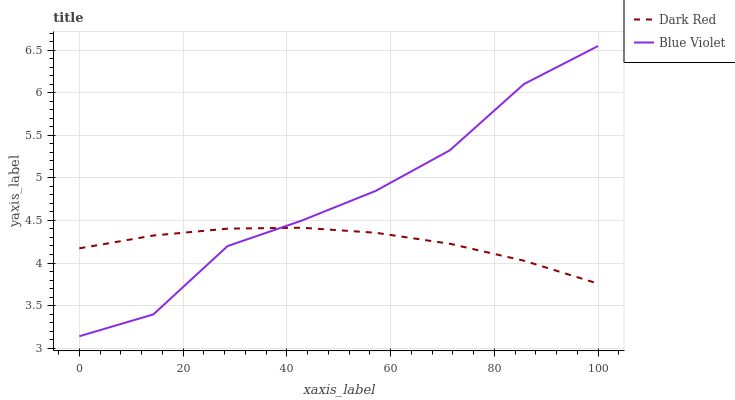Does Dark Red have the minimum area under the curve?
Answer yes or no. Yes. Does Blue Violet have the maximum area under the curve?
Answer yes or no. Yes. Does Blue Violet have the minimum area under the curve?
Answer yes or no. No. Is Dark Red the smoothest?
Answer yes or no. Yes. Is Blue Violet the roughest?
Answer yes or no. Yes. Is Blue Violet the smoothest?
Answer yes or no. No. Does Blue Violet have the lowest value?
Answer yes or no. Yes. Does Blue Violet have the highest value?
Answer yes or no. Yes. Does Blue Violet intersect Dark Red?
Answer yes or no. Yes. Is Blue Violet less than Dark Red?
Answer yes or no. No. Is Blue Violet greater than Dark Red?
Answer yes or no. No. 